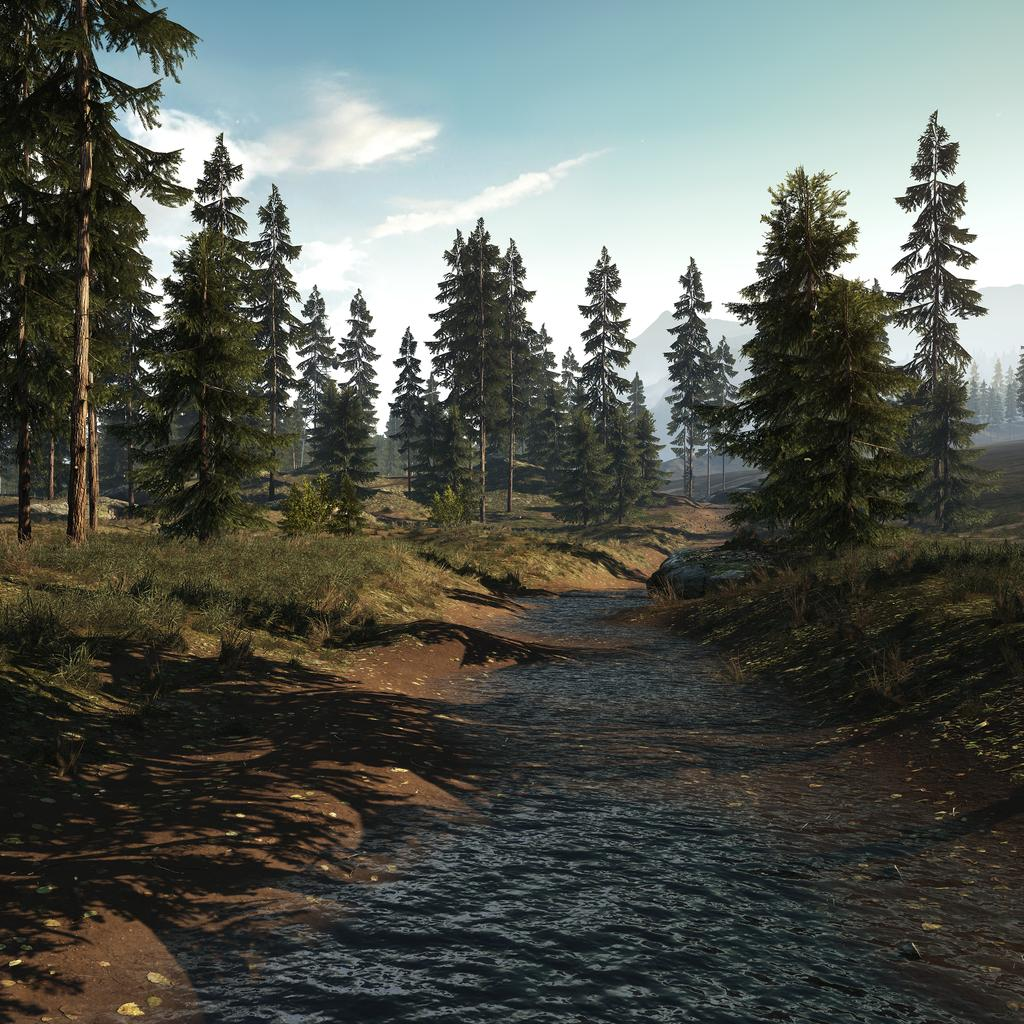What is the primary element flowing in the image? There is water flowing in the image. What type of vegetation is present on the surface near the water? There is grass on the surface on either side of the water. What can be seen in the background of the image? There are trees and mountains visible in the background of the image. What idea does the boy have while standing near the water in the image? There is no boy present in the image, so it is not possible to determine any ideas he might have. 